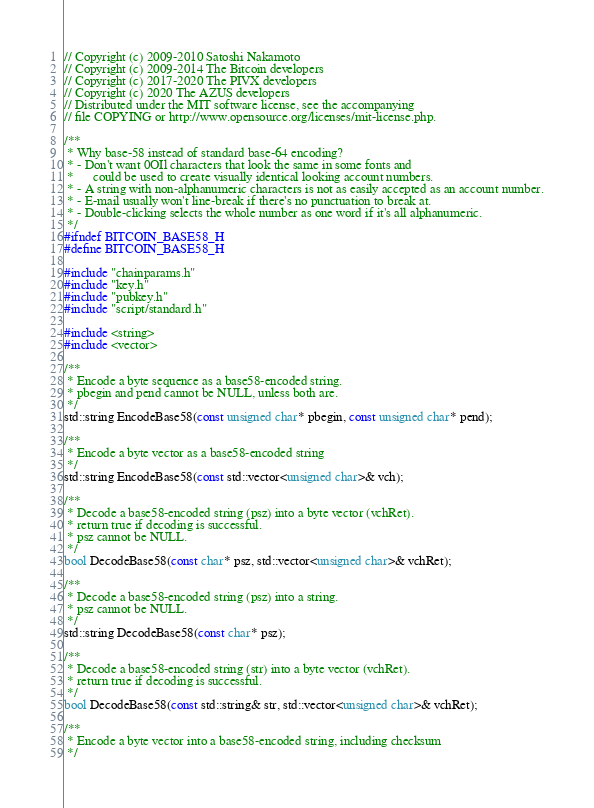<code> <loc_0><loc_0><loc_500><loc_500><_C_>// Copyright (c) 2009-2010 Satoshi Nakamoto
// Copyright (c) 2009-2014 The Bitcoin developers
// Copyright (c) 2017-2020 The PIVX developers
// Copyright (c) 2020 The AZUS developers
// Distributed under the MIT software license, see the accompanying
// file COPYING or http://www.opensource.org/licenses/mit-license.php.

/**
 * Why base-58 instead of standard base-64 encoding?
 * - Don't want 0OIl characters that look the same in some fonts and
 *      could be used to create visually identical looking account numbers.
 * - A string with non-alphanumeric characters is not as easily accepted as an account number.
 * - E-mail usually won't line-break if there's no punctuation to break at.
 * - Double-clicking selects the whole number as one word if it's all alphanumeric.
 */
#ifndef BITCOIN_BASE58_H
#define BITCOIN_BASE58_H

#include "chainparams.h"
#include "key.h"
#include "pubkey.h"
#include "script/standard.h"

#include <string>
#include <vector>

/**
 * Encode a byte sequence as a base58-encoded string.
 * pbegin and pend cannot be NULL, unless both are.
 */
std::string EncodeBase58(const unsigned char* pbegin, const unsigned char* pend);

/**
 * Encode a byte vector as a base58-encoded string
 */
std::string EncodeBase58(const std::vector<unsigned char>& vch);

/**
 * Decode a base58-encoded string (psz) into a byte vector (vchRet).
 * return true if decoding is successful.
 * psz cannot be NULL.
 */
bool DecodeBase58(const char* psz, std::vector<unsigned char>& vchRet);

/**
 * Decode a base58-encoded string (psz) into a string.
 * psz cannot be NULL.
 */
std::string DecodeBase58(const char* psz);

/**
 * Decode a base58-encoded string (str) into a byte vector (vchRet).
 * return true if decoding is successful.
 */
bool DecodeBase58(const std::string& str, std::vector<unsigned char>& vchRet);

/**
 * Encode a byte vector into a base58-encoded string, including checksum
 */</code> 